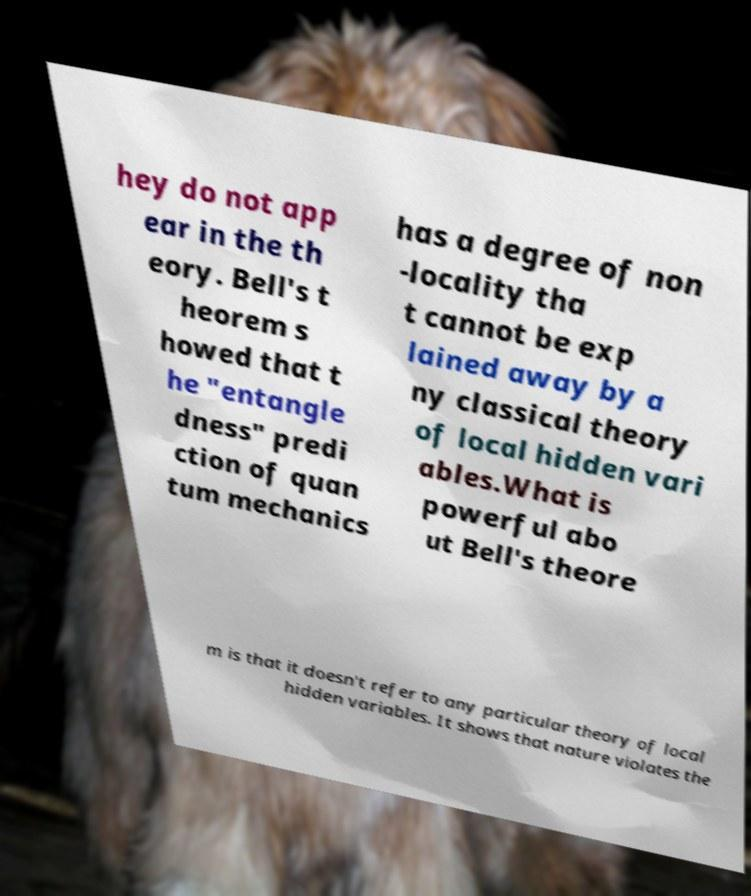Please identify and transcribe the text found in this image. hey do not app ear in the th eory. Bell's t heorem s howed that t he "entangle dness" predi ction of quan tum mechanics has a degree of non -locality tha t cannot be exp lained away by a ny classical theory of local hidden vari ables.What is powerful abo ut Bell's theore m is that it doesn't refer to any particular theory of local hidden variables. It shows that nature violates the 